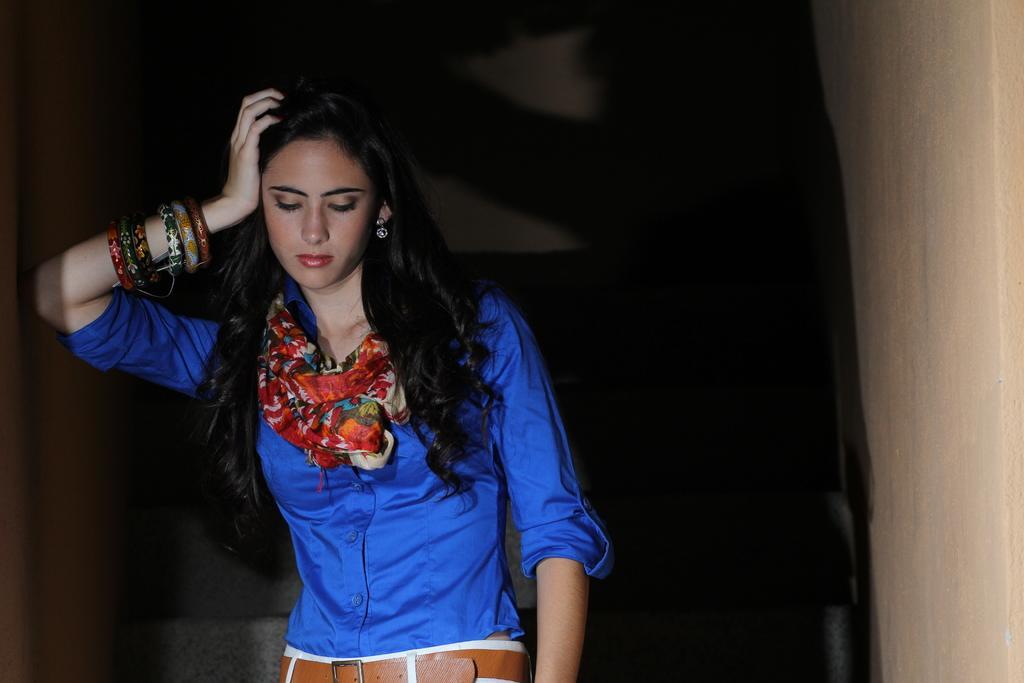Can you describe this image briefly? Here we can see a woman and wall. There is a dark background. 